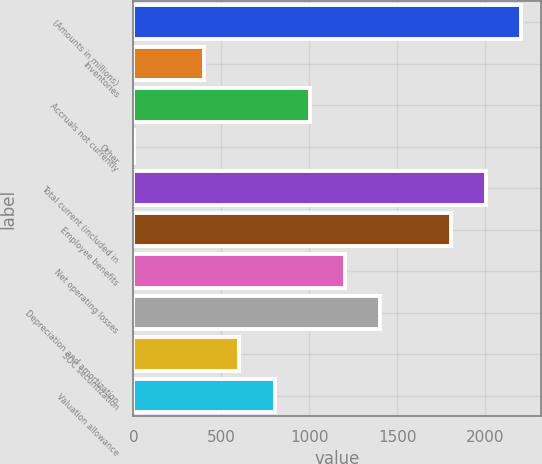Convert chart. <chart><loc_0><loc_0><loc_500><loc_500><bar_chart><fcel>(Amounts in millions)<fcel>Inventories<fcel>Accruals not currently<fcel>Other<fcel>Total current (included in<fcel>Employee benefits<fcel>Net operating losses<fcel>Depreciation and amortization<fcel>SOC securitization<fcel>Valuation allowance<nl><fcel>2205.32<fcel>402.44<fcel>1003.4<fcel>1.8<fcel>2005<fcel>1804.68<fcel>1203.72<fcel>1404.04<fcel>602.76<fcel>803.08<nl></chart> 